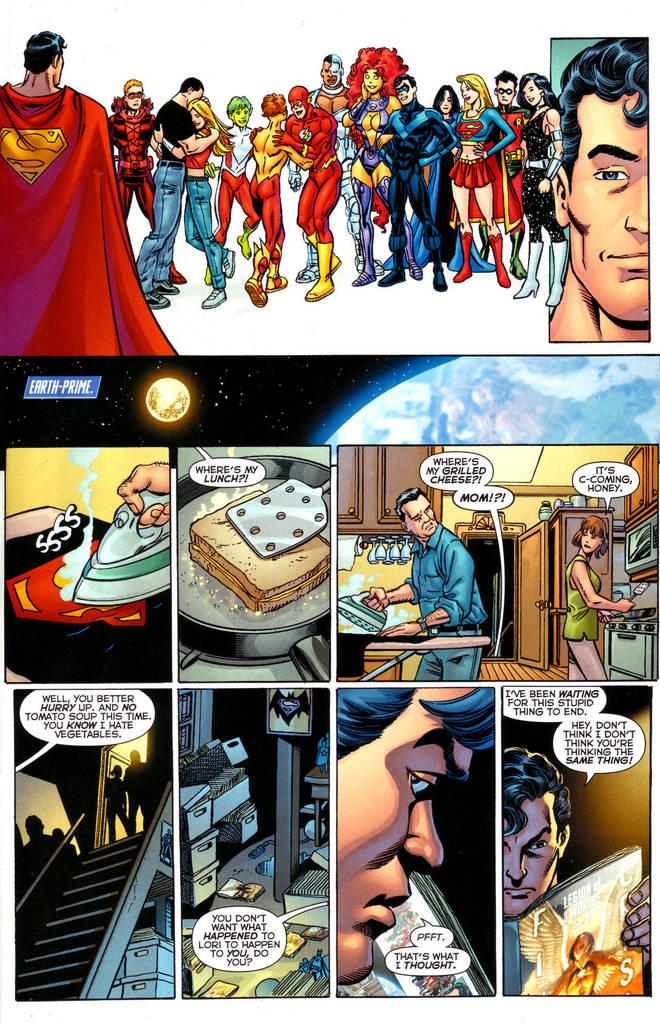What type of pictures can be seen in the image? There are cartoon pictures in the image. Is there any text present in the image? Yes, there is text written on the image. How many bikes are parked next to the cartoon pictures in the image? There are no bikes present in the image; it only contains cartoon pictures and text. What type of snails can be seen interacting with the cartoon pictures in the image? There are no snails present in the image; it only contains cartoon pictures and text. 